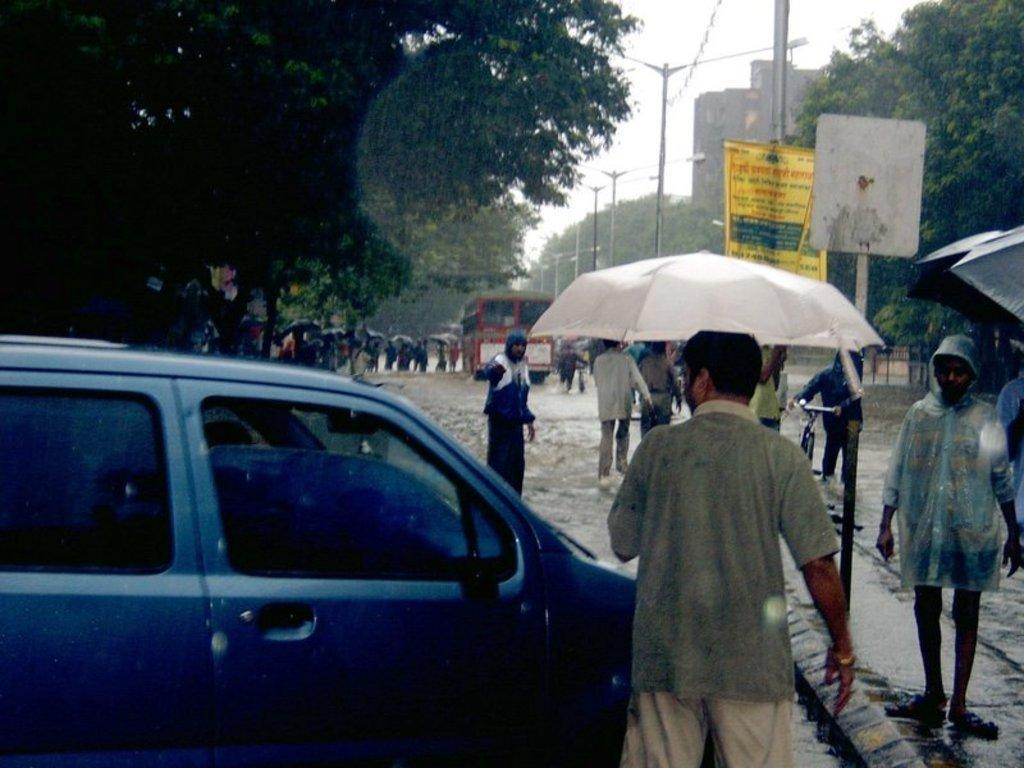Please provide a concise description of this image. In this image we can see a group of people standing on the ground. Some persons are holding umbrellas in their hands. Some vehicles are parked on the ground. On the right side of the image we can see a banner with some text, sign board. One person is holding a bicycle with his hands. In the background, we can see group of light poles, group of trees, building and the sky. 